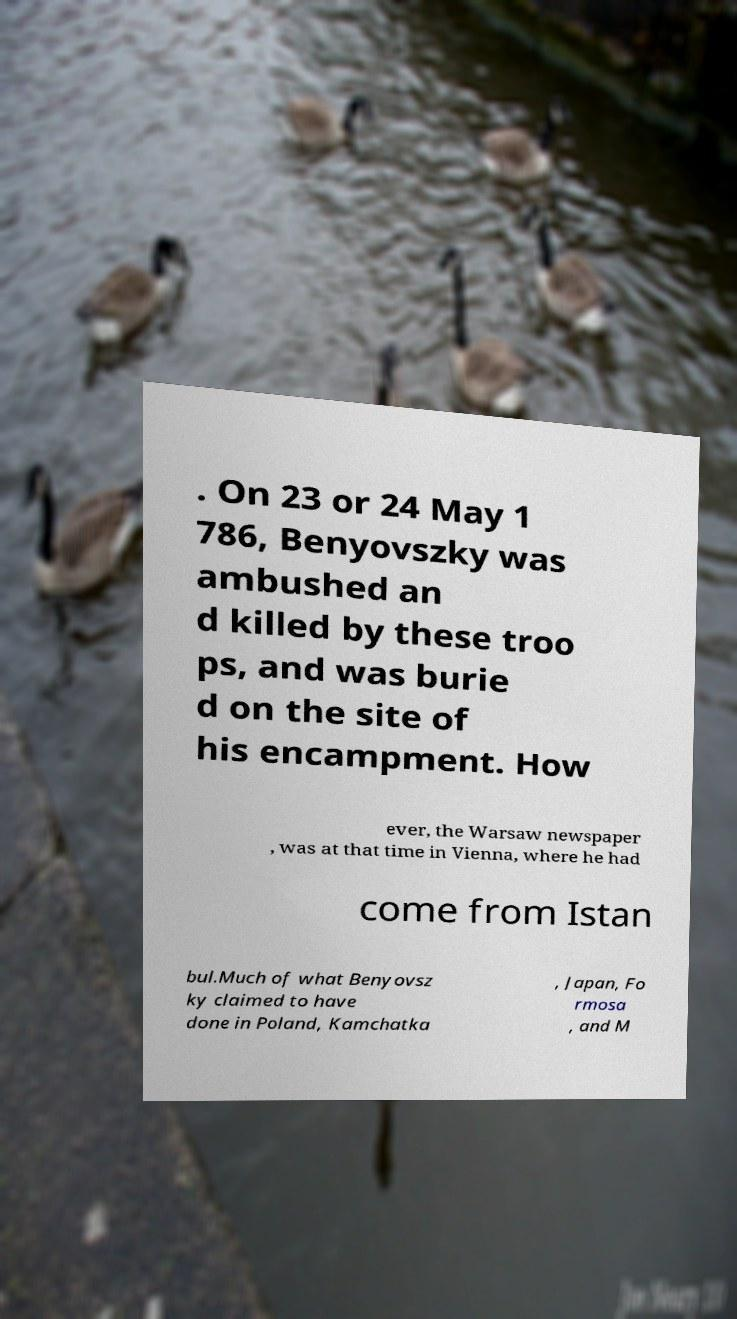Please identify and transcribe the text found in this image. . On 23 or 24 May 1 786, Benyovszky was ambushed an d killed by these troo ps, and was burie d on the site of his encampment. How ever, the Warsaw newspaper , was at that time in Vienna, where he had come from Istan bul.Much of what Benyovsz ky claimed to have done in Poland, Kamchatka , Japan, Fo rmosa , and M 